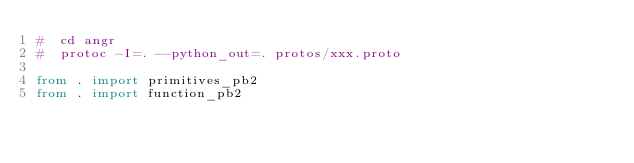<code> <loc_0><loc_0><loc_500><loc_500><_Python_>#  cd angr
#  protoc -I=. --python_out=. protos/xxx.proto

from . import primitives_pb2
from . import function_pb2
</code> 